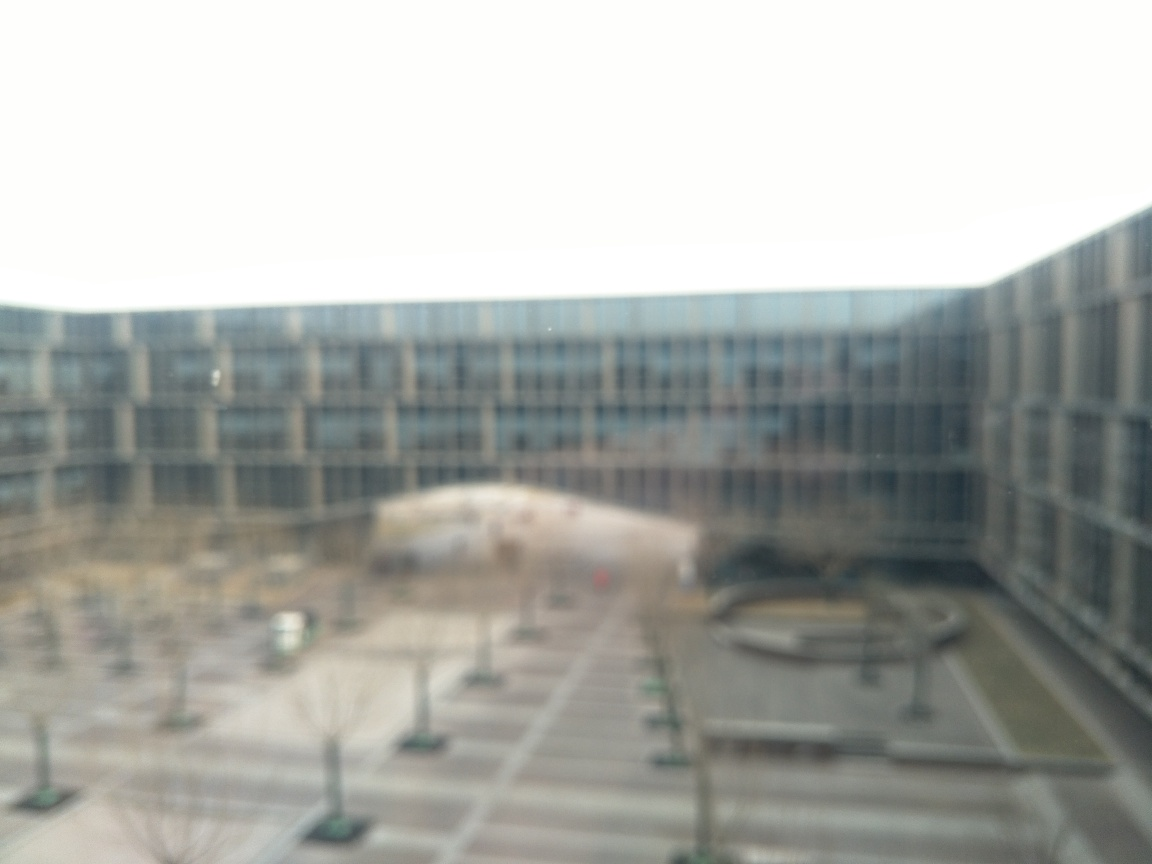What mood does this image convey to you? The image seems to convey a sense of quietness and stillness, perhaps due to the lack of visible activity and the muted, uniform colors. The blurry quality adds to the atmosphere, giving a feeling of solitude or introspection. It could be interpreted as a calm oasis amidst a busy environment or as an image capturing a moment of stillness in time. 